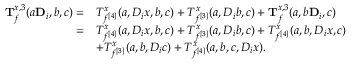<formula> <loc_0><loc_0><loc_500><loc_500>\begin{array} { r l } { \mathbf T _ { f } ^ { x , 3 } ( a \mathbf D _ { i } , b , c ) = } & { T _ { f ^ { [ 4 ] } } ^ { x } ( a , D _ { i } x , b , c ) + T _ { f ^ { [ 3 ] } } ^ { x } ( a , D _ { i } b , c ) + \mathbf T _ { f } ^ { x , 3 } ( a , b \mathbf D _ { i } , c ) } \\ { = } & { T _ { f ^ { [ 4 ] } } ^ { x } ( a , D _ { i } x , b , c ) + T _ { f ^ { [ 3 ] } } ^ { x } ( a , D _ { i } b , c ) + T _ { f ^ { [ 4 ] } } ^ { x } ( a , b , D _ { i } x , c ) } \\ & { + T _ { f ^ { [ 3 ] } } ^ { x } ( a , b , D _ { i } c ) + T _ { f ^ { [ 4 ] } } ^ { x } ( a , b , c , D _ { i } x ) . } \end{array}</formula> 